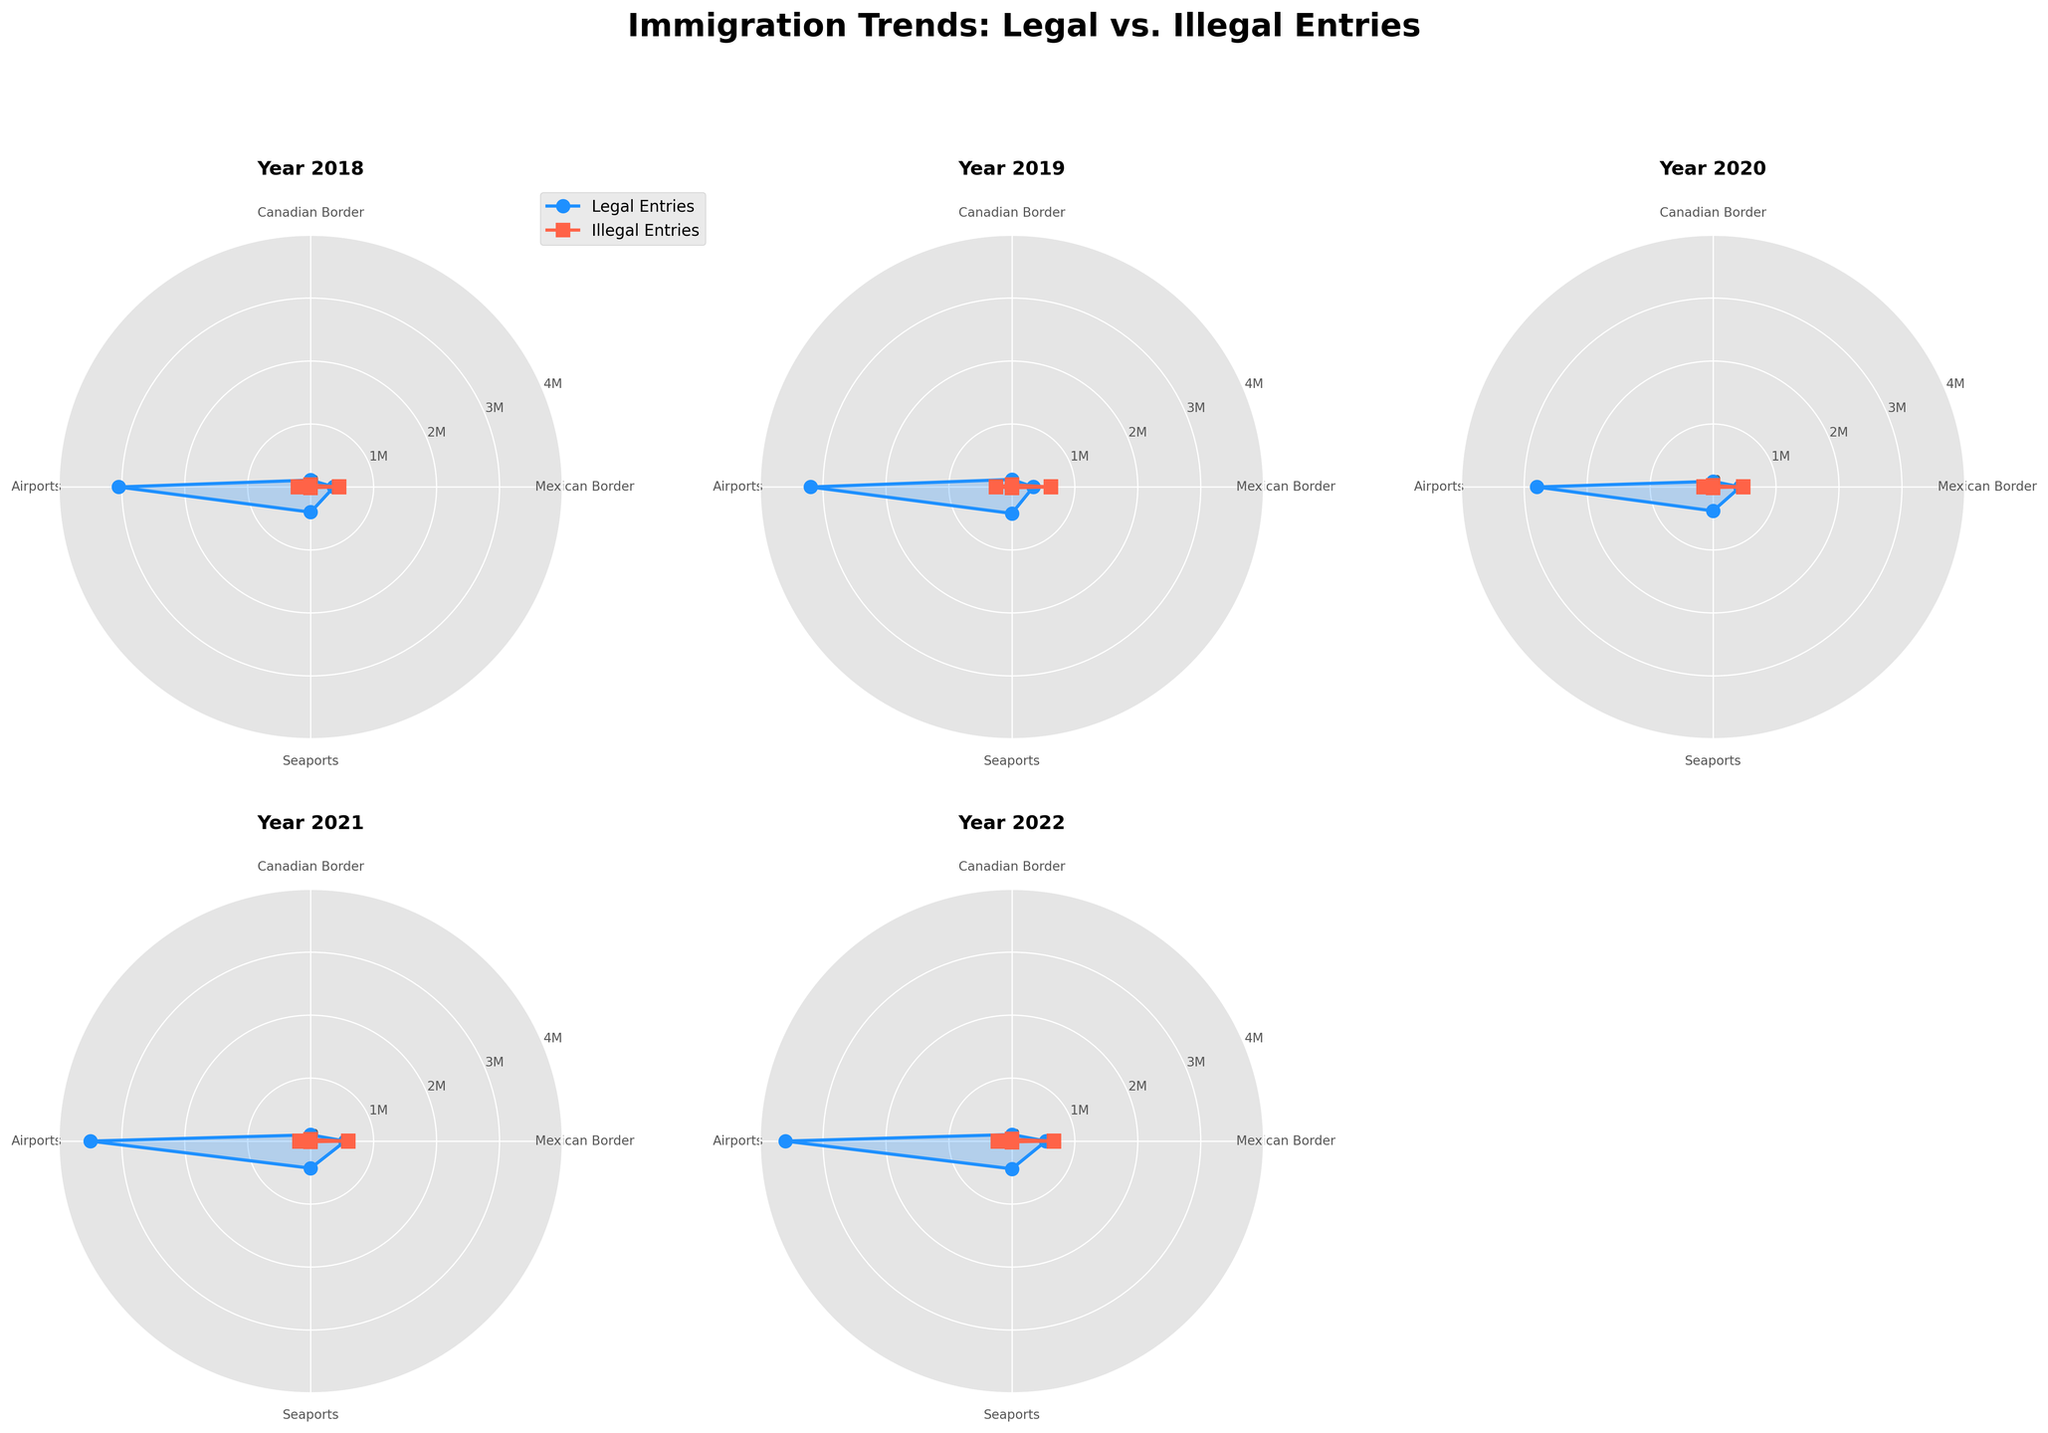What is the title of the figure? The title is located at the top of the figure and reads "Immigration Trends: Legal vs. Illegal Entries".
Answer: Immigration Trends: Legal vs. Illegal Entries Which category had the highest number of legal entries in 2022? By observing the plot for 2022, the data point for "Airports" is highest in the legal entries line, reaching approximately 3.6 million.
Answer: Airports In which year did the Mexican Border have the highest number of illegal entries? Looking at the radar plots for the Mexican Border across years, 2019 and 2022 have the peaks in illegal entries. By comparing both on the radar chart, 2022 is higher.
Answer: 2022 What's the sum of legal entries through Seaports from 2018 to 2022? Adding the legal entries for Seaports from each year's plot: 400,000 + 420,000 + 380,000 + 430,000 + 440,000, results in the total of 2,070,000.
Answer: 2,070,000 How did illegal entries at the Canadian Border change from 2018 to 2020? Comparing the radar plots for the Canadian Border over these three years shows a decrease: from 30,000 in 2018 to 20,000 in 2020.
Answer: Decreased Which year shows the largest gap between legal and illegal entries at the Mexican Border? Examining the radar plots, the year 2019 shows the largest gap between 340,000 legal and 620,000 illegal entries which is a difference of 280,000.
Answer: 2019 Is the trend of illegal entries at Airports increasing from 2018 to 2022? By checking the radar plots from 2018 to 2022 for Airports, we see illegal entries rise from 200,000 to 220,000.
Answer: Yes, increasing What was the approximate difference between legal entries and illegal entries at Seaports in 2021? In 2021's radar plot, legal entries at Seaports were about 430,000 and illegal entries were around 9,000, so the difference is approximately 421,000.
Answer: 421,000 Did Canadian Border have more illegal entries or Seaports in 2018? In the 2018 radar plot, Canadian Border had 30,000 illegal entries while Seaports had 10,000. Therefore, the Canadian Border had more illegal entries.
Answer: Canadian Border Which category experienced the least fluctuation in legal entries from 2018 to 2022? By analyzing the radar plots, Seaports have the most consistent legal entry values, ranging roughly between 380,000 and 440,000 across the years.
Answer: Seaports 